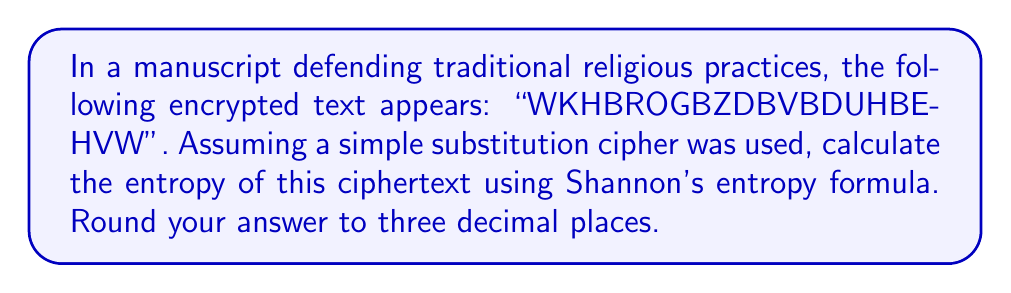Could you help me with this problem? To calculate the entropy of the ciphertext using Shannon's entropy formula, we'll follow these steps:

1. Count the frequency of each letter in the ciphertext:
   B: 5, D: 2, H: 3, K: 1, G: 1, V: 1, W: 2, Z: 1

2. Calculate the probability of each letter:
   P(B) = 5/20 = 0.25
   P(D) = 2/20 = 0.10
   P(H) = 3/20 = 0.15
   P(K) = 1/20 = 0.05
   P(G) = 1/20 = 0.05
   P(V) = 1/20 = 0.05
   P(W) = 2/20 = 0.10
   P(Z) = 1/20 = 0.05

3. Apply Shannon's entropy formula:
   $$H = -\sum_{i=1}^n p_i \log_2(p_i)$$

   Where $p_i$ is the probability of each letter and $n$ is the number of unique letters.

4. Calculate each term:
   $-0.25 \log_2(0.25) = 0.5$
   $-0.10 \log_2(0.10) = 0.332$
   $-0.15 \log_2(0.15) = 0.411$
   $-0.05 \log_2(0.05) = 0.216$ (this appears 4 times)
   $-0.10 \log_2(0.10) = 0.332$

5. Sum all terms:
   $H = 0.5 + 0.332 + 0.411 + (4 * 0.216) + 0.332 = 2.439$

6. Round to three decimal places: 2.439
Answer: 2.439 